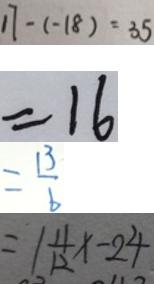<formula> <loc_0><loc_0><loc_500><loc_500>1 7 - ( - 1 8 ) = 3 5 
 = 1 6 
 = \frac { 1 3 } { 6 } 
 = 1 \frac { 1 1 } { 1 2 } x - 2 4</formula> 